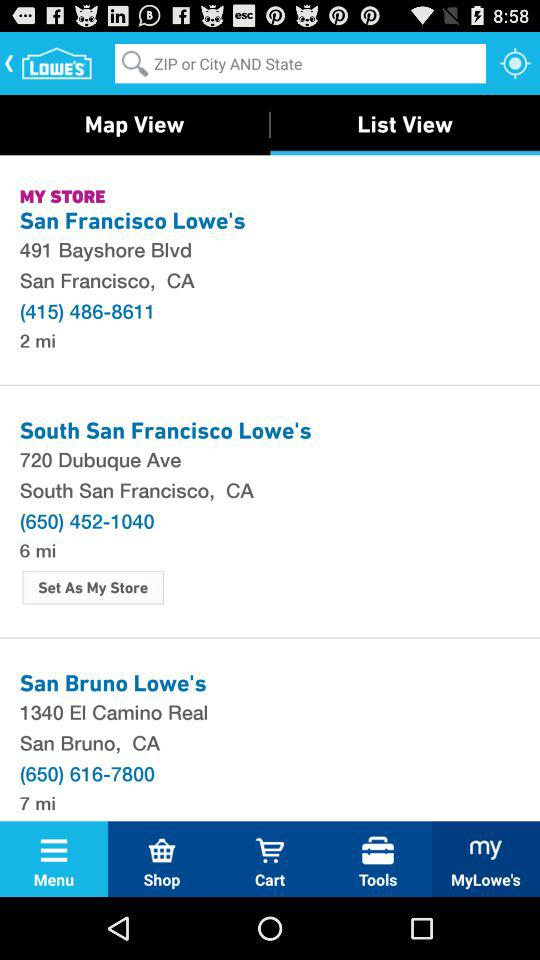How far is San Bruno Lowe's? The San Bruno Lowe's is 7 miles away. 